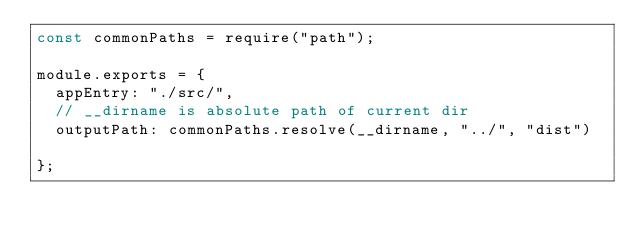Convert code to text. <code><loc_0><loc_0><loc_500><loc_500><_JavaScript_>const commonPaths = require("path");

module.exports = {
  appEntry: "./src/",
  // __dirname is absolute path of current dir
  outputPath: commonPaths.resolve(__dirname, "../", "dist")

};</code> 